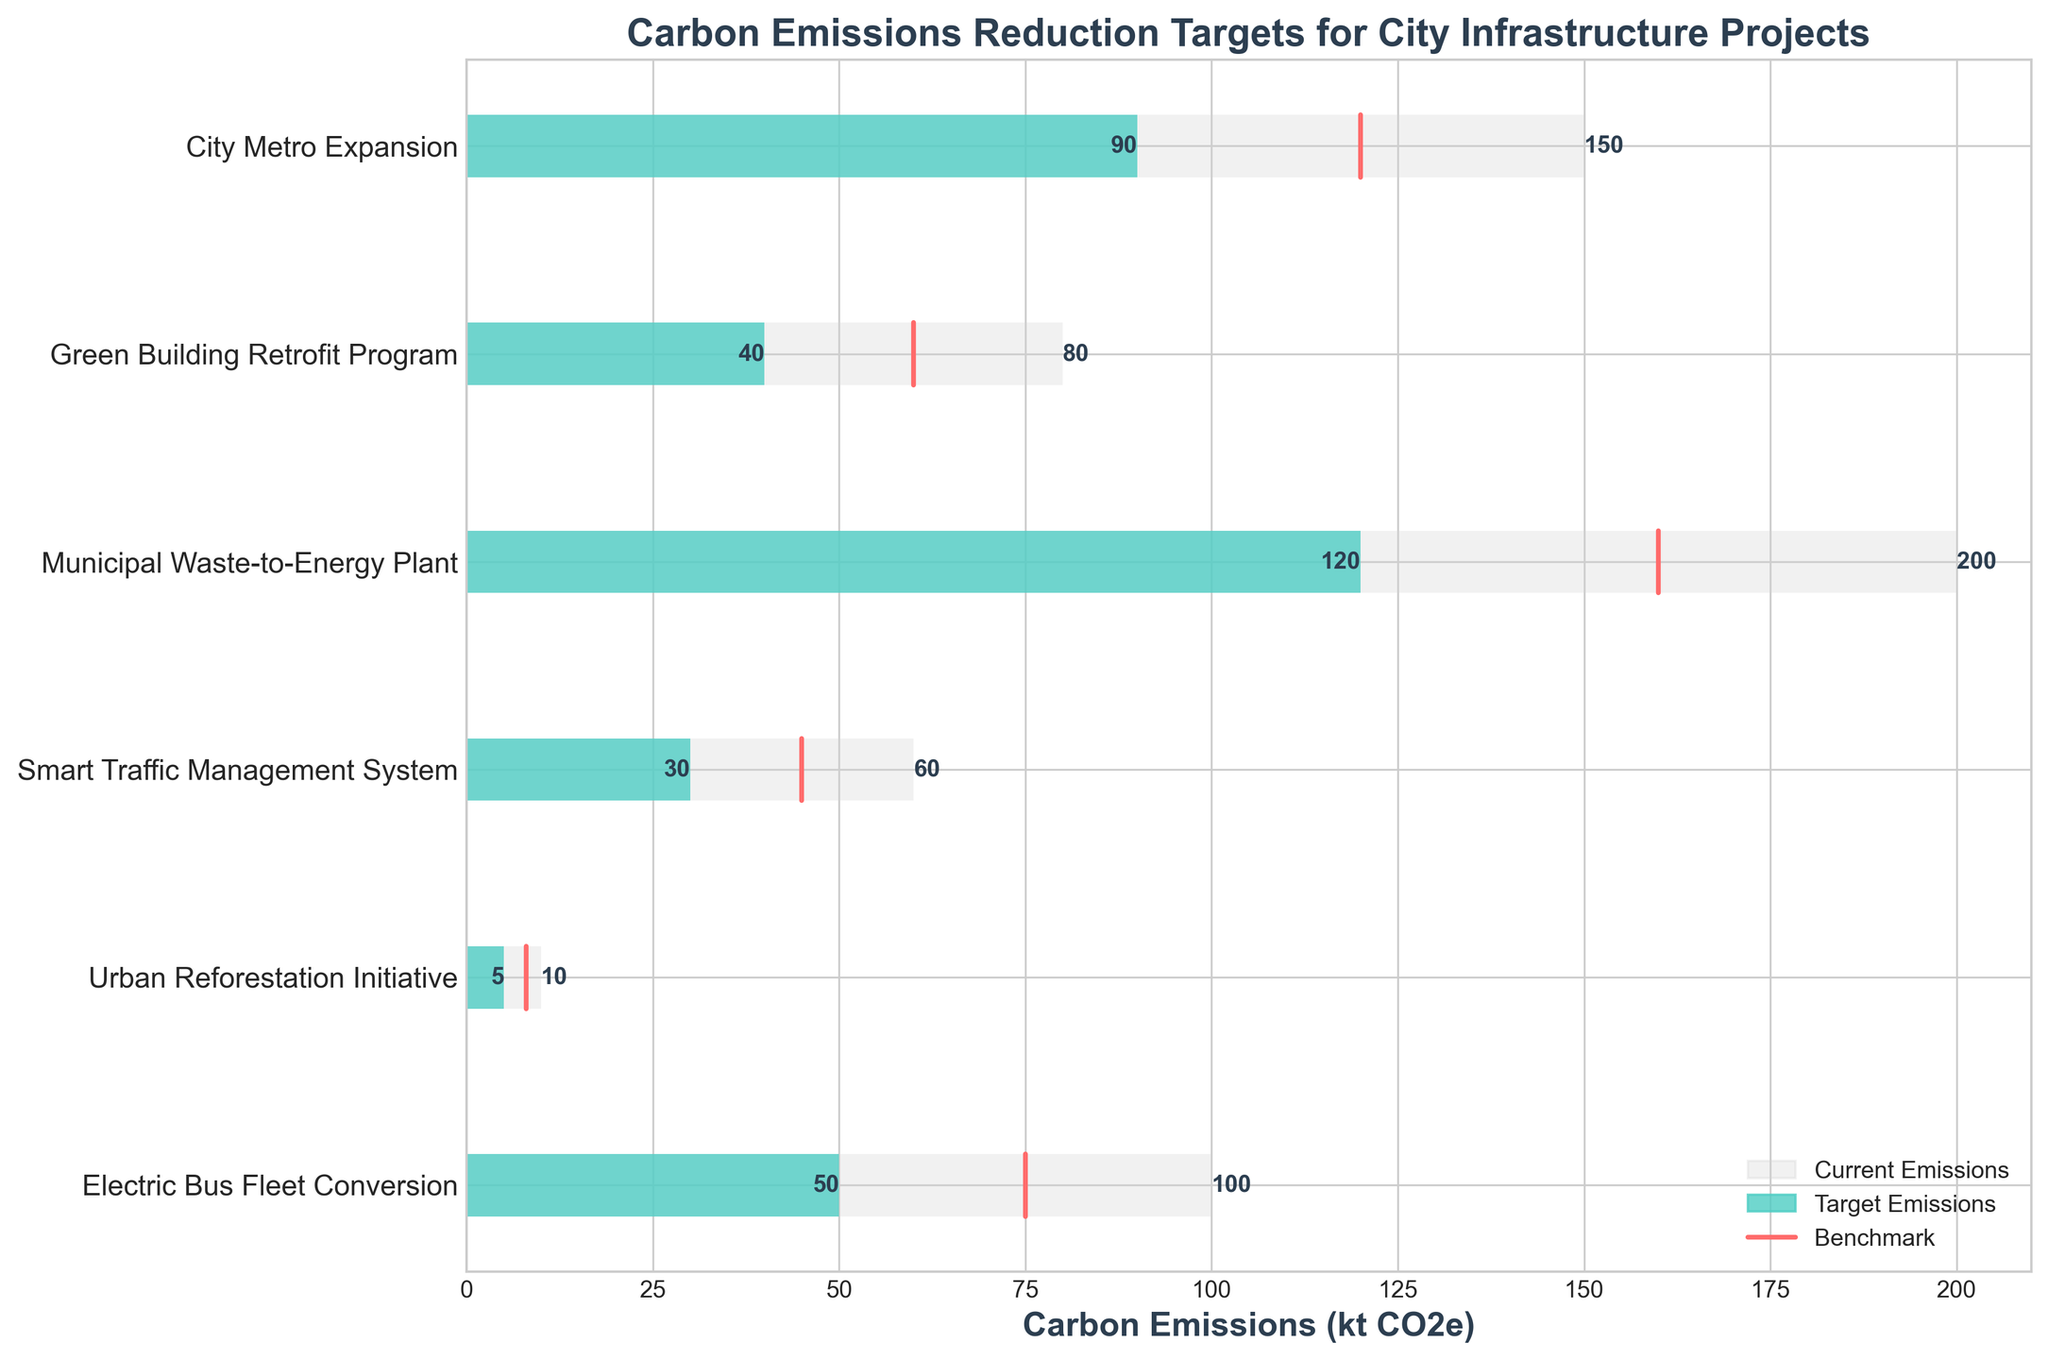What is the title of the figure? The title of the figure is prominently displayed at the top. It reads "Carbon Emissions Reduction Targets for City Infrastructure Projects".
Answer: Carbon Emissions Reduction Targets for City Infrastructure Projects What is the color used to represent current emissions? The bars representing current emissions are shown in light grey color.
Answer: Light grey How many projects have their target emissions below the benchmark? To determine this, compare the target emissions bars with the benchmark lines for each project. The projects where the target bar is to the left of the benchmark line are considered.
Answer: Six projects Which project has the highest current emissions? Look at the length of the light grey bars and find the project with the longest bar. "Municipal Waste-to-Energy Plant" has the highest current emissions at 200 kt CO2e.
Answer: Municipal Waste-to-Energy Plant What is the difference in target emissions between the City Metro Expansion and Electric Bus Fleet Conversion? The target emissions for the City Metro Expansion are 90 kt CO2e and for the Electric Bus Fleet Conversion are 50 kt CO2e. Subtract the smaller number from the larger number (90 - 50).
Answer: 40 kt CO2e Which project aims to reduce its emissions by more than half of its current levels? For each project, compare the target emissions to half of the current emissions to see if the target is lower. The "Smart Traffic Management System" aims to reduce from 60 to 30, and 30 is half of 60.
Answer: Smart Traffic Management System What is the sum of the target emissions for all projects combined? Add the target emissions for all projects: 90 + 40 + 120 + 30 + 5 + 50.
Answer: 335 kt CO2e Which project has the smallest difference between benchmark emissions and current emissions? Calculate the difference between benchmark emissions and current emissions for each project, and find the smallest. It is 10 kt CO2e for "Urban Reforestation Initiative" (10 - 8).
Answer: Urban Reforestation Initiative Between the "Green Building Retrofit Program" and "Smart Traffic Management System", which has higher benchmark emissions? Compare the benchmark emissions of the two projects to see which one is higher. The "Green Building Retrofit Program" has a benchmark of 60 which is higher than 45 for "Smart Traffic Management System".
Answer: Green Building Retrofit Program 